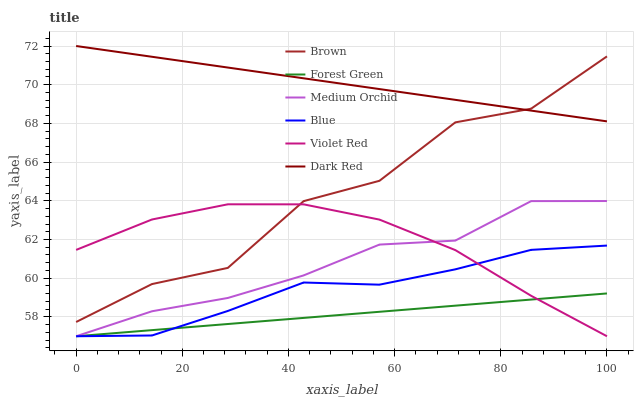Does Forest Green have the minimum area under the curve?
Answer yes or no. Yes. Does Dark Red have the maximum area under the curve?
Answer yes or no. Yes. Does Brown have the minimum area under the curve?
Answer yes or no. No. Does Brown have the maximum area under the curve?
Answer yes or no. No. Is Forest Green the smoothest?
Answer yes or no. Yes. Is Brown the roughest?
Answer yes or no. Yes. Is Violet Red the smoothest?
Answer yes or no. No. Is Violet Red the roughest?
Answer yes or no. No. Does Brown have the lowest value?
Answer yes or no. No. Does Dark Red have the highest value?
Answer yes or no. Yes. Does Brown have the highest value?
Answer yes or no. No. Is Forest Green less than Brown?
Answer yes or no. Yes. Is Brown greater than Medium Orchid?
Answer yes or no. Yes. Does Brown intersect Violet Red?
Answer yes or no. Yes. Is Brown less than Violet Red?
Answer yes or no. No. Is Brown greater than Violet Red?
Answer yes or no. No. Does Forest Green intersect Brown?
Answer yes or no. No. 